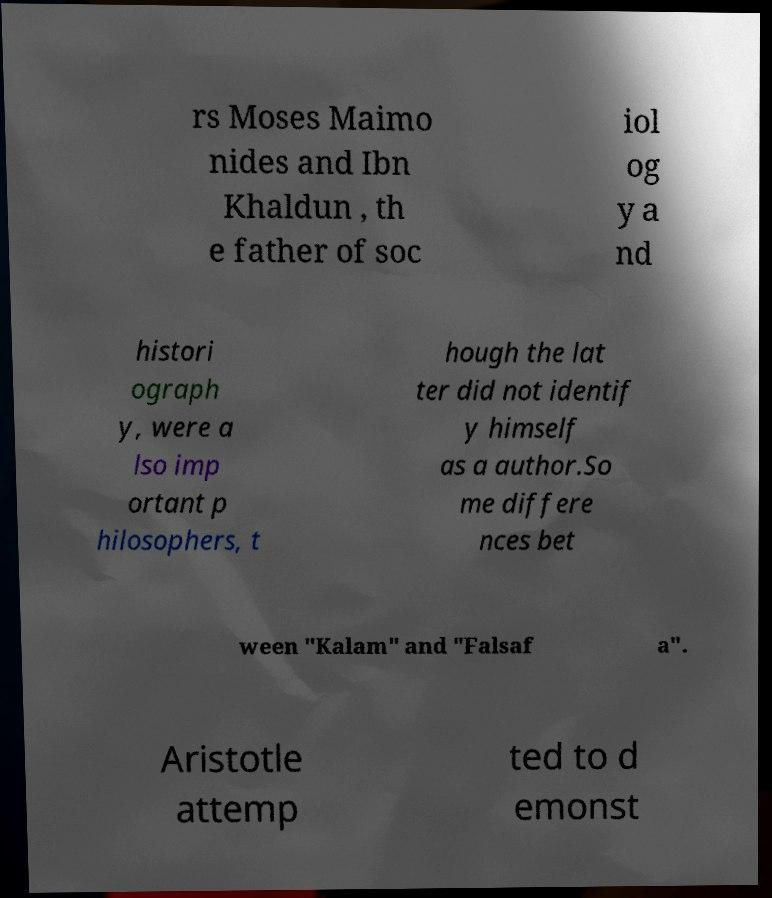There's text embedded in this image that I need extracted. Can you transcribe it verbatim? rs Moses Maimo nides and Ibn Khaldun , th e father of soc iol og y a nd histori ograph y, were a lso imp ortant p hilosophers, t hough the lat ter did not identif y himself as a author.So me differe nces bet ween "Kalam" and "Falsaf a". Aristotle attemp ted to d emonst 